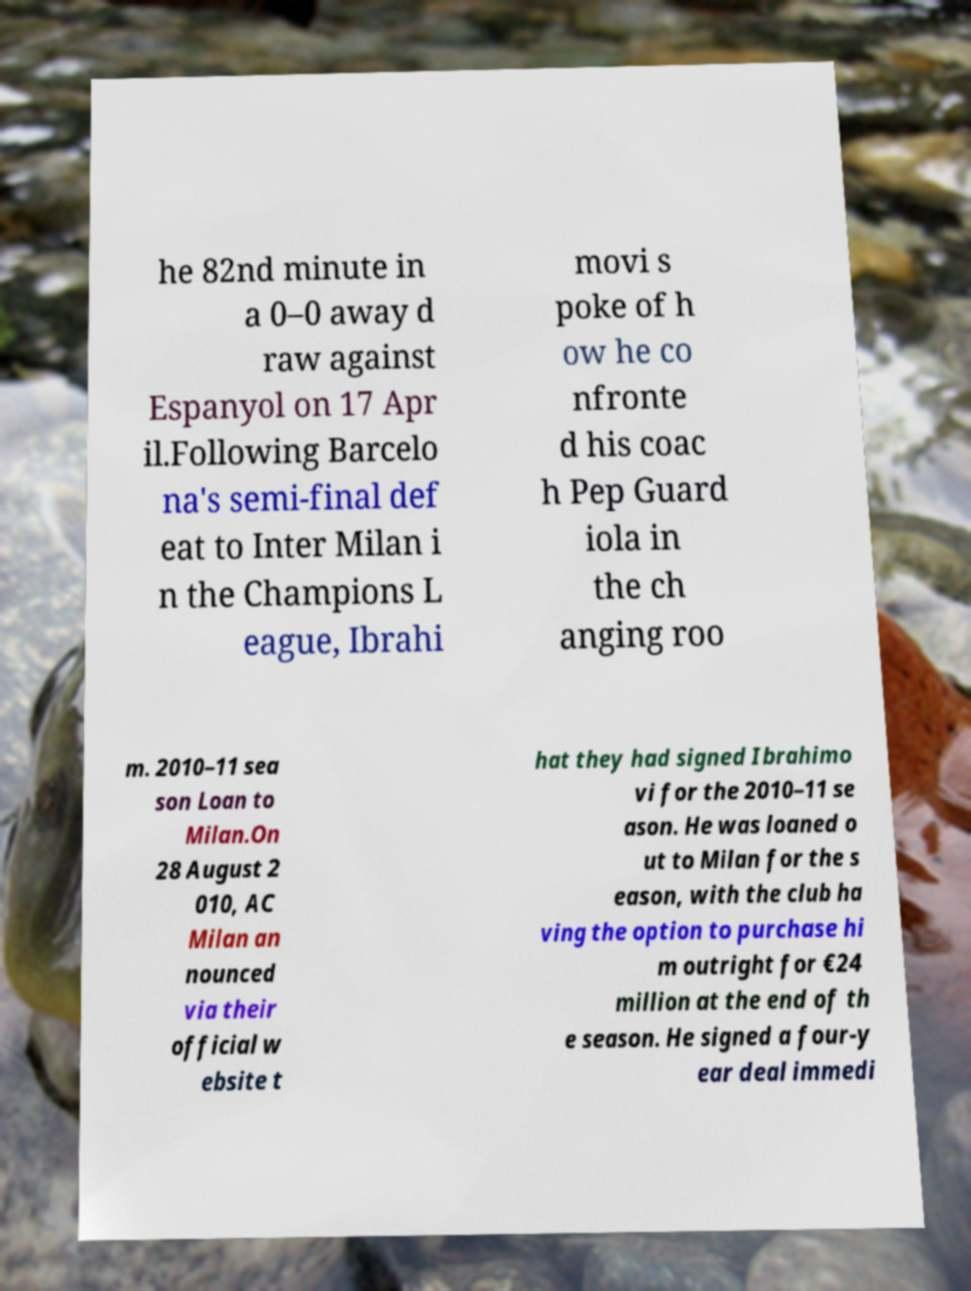For documentation purposes, I need the text within this image transcribed. Could you provide that? he 82nd minute in a 0–0 away d raw against Espanyol on 17 Apr il.Following Barcelo na's semi-final def eat to Inter Milan i n the Champions L eague, Ibrahi movi s poke of h ow he co nfronte d his coac h Pep Guard iola in the ch anging roo m. 2010–11 sea son Loan to Milan.On 28 August 2 010, AC Milan an nounced via their official w ebsite t hat they had signed Ibrahimo vi for the 2010–11 se ason. He was loaned o ut to Milan for the s eason, with the club ha ving the option to purchase hi m outright for €24 million at the end of th e season. He signed a four-y ear deal immedi 